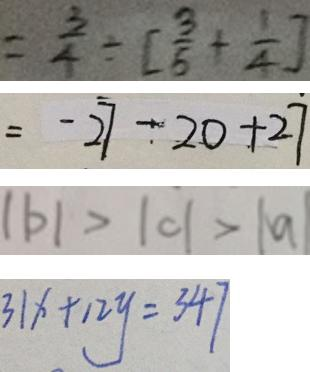Convert formula to latex. <formula><loc_0><loc_0><loc_500><loc_500>= \frac { 3 } { 4 } \div [ \frac { 3 } { 5 } + \frac { 1 } { 4 } ] 
 = - 2 7 - 2 0 + 2 7 
 \vert b \vert > \vert c \vert > \vert a \vert 
 3 1 x + 1 2 y = 3 4 7</formula> 